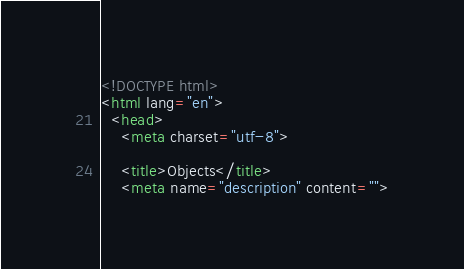<code> <loc_0><loc_0><loc_500><loc_500><_HTML_><!DOCTYPE html>
<html lang="en">
  <head>
    <meta charset="utf-8">

    <title>Objects</title>
    <meta name="description" content=""></code> 